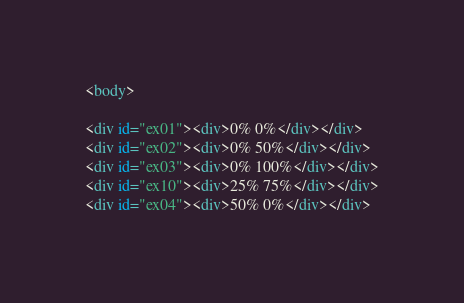<code> <loc_0><loc_0><loc_500><loc_500><_HTML_><body>

<div id="ex01"><div>0% 0%</div></div>
<div id="ex02"><div>0% 50%</div></div>
<div id="ex03"><div>0% 100%</div></div>
<div id="ex10"><div>25% 75%</div></div>
<div id="ex04"><div>50% 0%</div></div></code> 